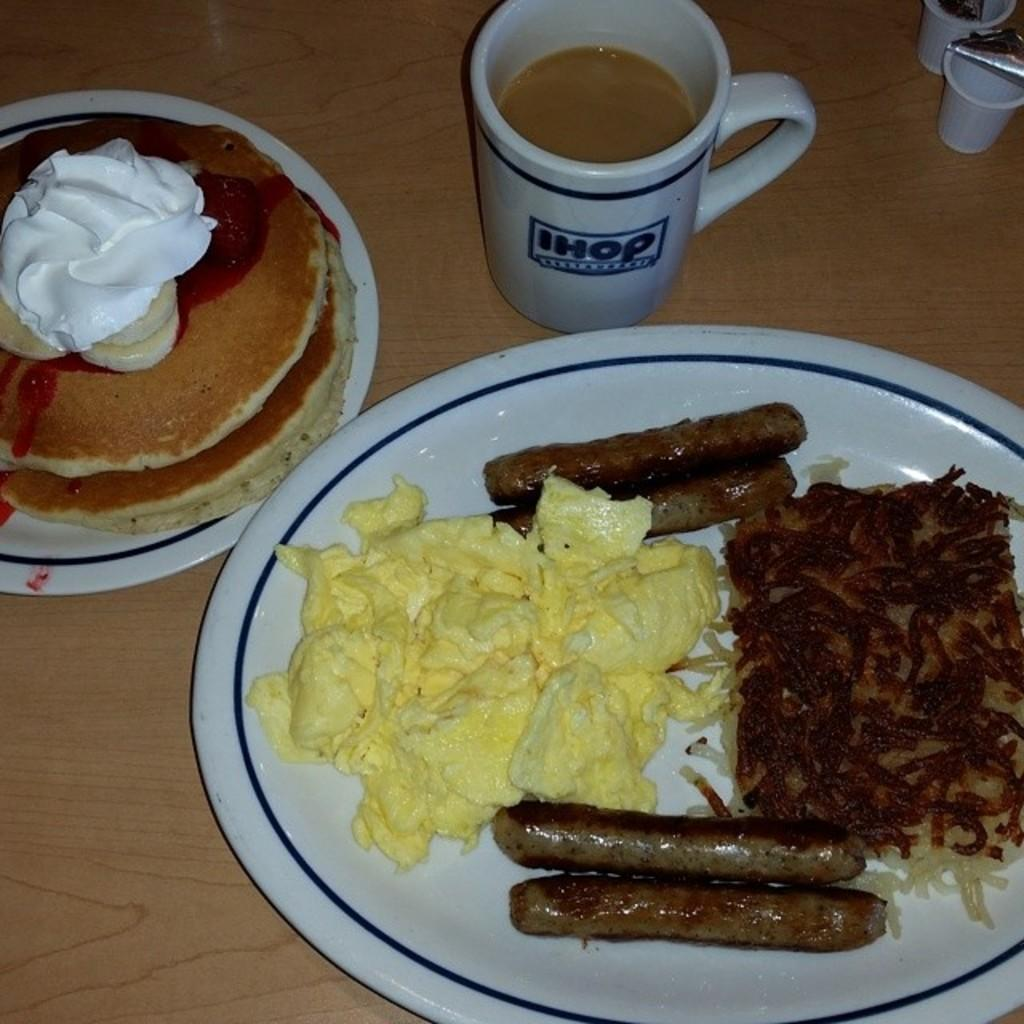What can be seen on the plates in the image? There are different food items on plates in the image. How many plates are visible in the image? There are plates visible in the image. What is the cup used for in the image? The cup is likely used for holding a beverage in the image. What is the table holding in the image? The table is holding plates, food items, and a cup in the image. What note is the musician playing in the image? There is no musician or note present in the image; it only features food items on plates, plates, a cup, and objects on a table. 